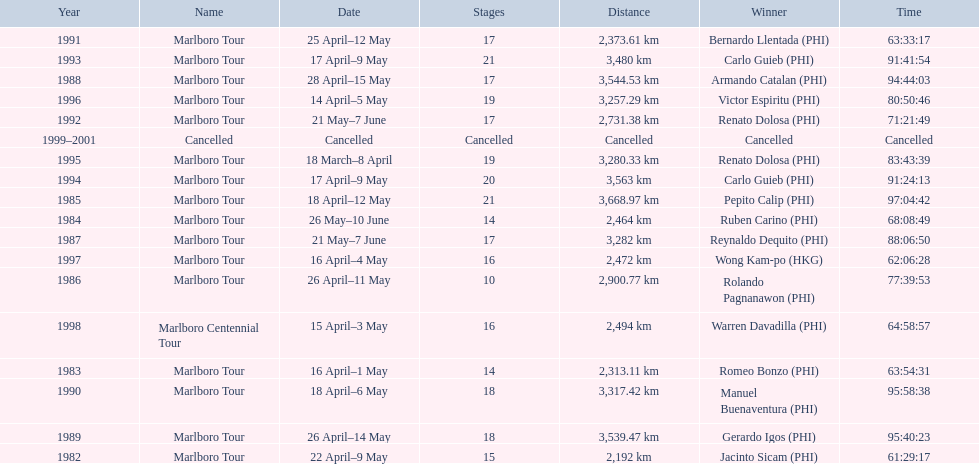How far did the marlboro tour travel each year? 2,192 km, 2,313.11 km, 2,464 km, 3,668.97 km, 2,900.77 km, 3,282 km, 3,544.53 km, 3,539.47 km, 3,317.42 km, 2,373.61 km, 2,731.38 km, 3,480 km, 3,563 km, 3,280.33 km, 3,257.29 km, 2,472 km, 2,494 km, Cancelled. In what year did they travel the furthest? 1985. How far did they travel that year? 3,668.97 km. 